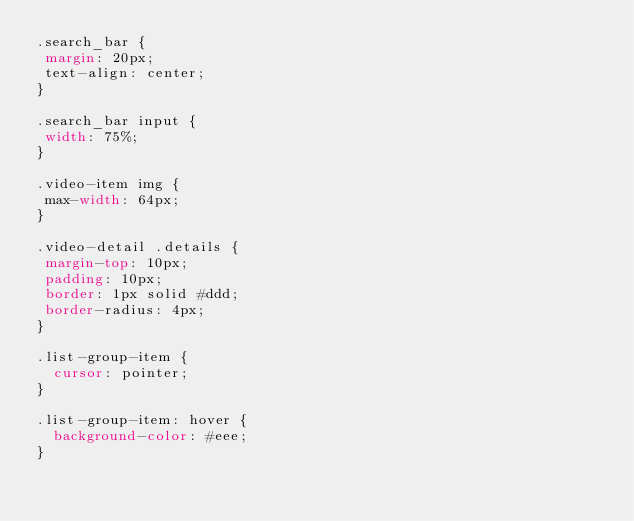Convert code to text. <code><loc_0><loc_0><loc_500><loc_500><_CSS_>.search_bar {
 margin: 20px;
 text-align: center;
}

.search_bar input {
 width: 75%;
}

.video-item img {
 max-width: 64px;
}

.video-detail .details {
 margin-top: 10px;
 padding: 10px;
 border: 1px solid #ddd;
 border-radius: 4px;
}

.list-group-item {
  cursor: pointer;
}

.list-group-item: hover {
  background-color: #eee;
}
</code> 